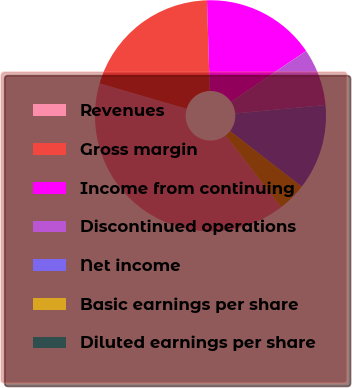Convert chart to OTSL. <chart><loc_0><loc_0><loc_500><loc_500><pie_chart><fcel>Revenues<fcel>Gross margin<fcel>Income from continuing<fcel>Discontinued operations<fcel>Net income<fcel>Basic earnings per share<fcel>Diluted earnings per share<nl><fcel>39.99%<fcel>20.0%<fcel>16.0%<fcel>8.0%<fcel>12.0%<fcel>4.0%<fcel>0.0%<nl></chart> 